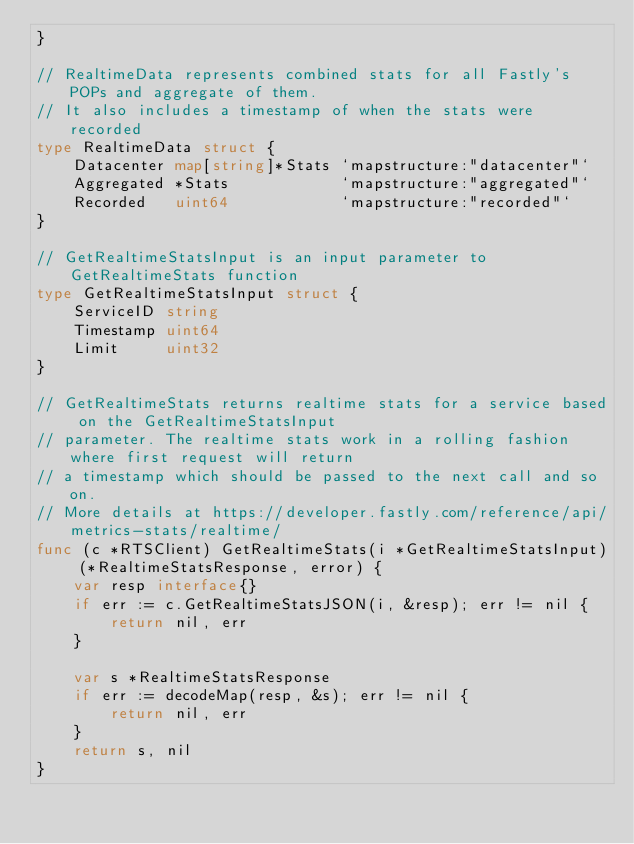<code> <loc_0><loc_0><loc_500><loc_500><_Go_>}

// RealtimeData represents combined stats for all Fastly's POPs and aggregate of them.
// It also includes a timestamp of when the stats were recorded
type RealtimeData struct {
	Datacenter map[string]*Stats `mapstructure:"datacenter"`
	Aggregated *Stats            `mapstructure:"aggregated"`
	Recorded   uint64            `mapstructure:"recorded"`
}

// GetRealtimeStatsInput is an input parameter to GetRealtimeStats function
type GetRealtimeStatsInput struct {
	ServiceID string
	Timestamp uint64
	Limit     uint32
}

// GetRealtimeStats returns realtime stats for a service based on the GetRealtimeStatsInput
// parameter. The realtime stats work in a rolling fashion where first request will return
// a timestamp which should be passed to the next call and so on.
// More details at https://developer.fastly.com/reference/api/metrics-stats/realtime/
func (c *RTSClient) GetRealtimeStats(i *GetRealtimeStatsInput) (*RealtimeStatsResponse, error) {
	var resp interface{}
	if err := c.GetRealtimeStatsJSON(i, &resp); err != nil {
		return nil, err
	}

	var s *RealtimeStatsResponse
	if err := decodeMap(resp, &s); err != nil {
		return nil, err
	}
	return s, nil
}
</code> 